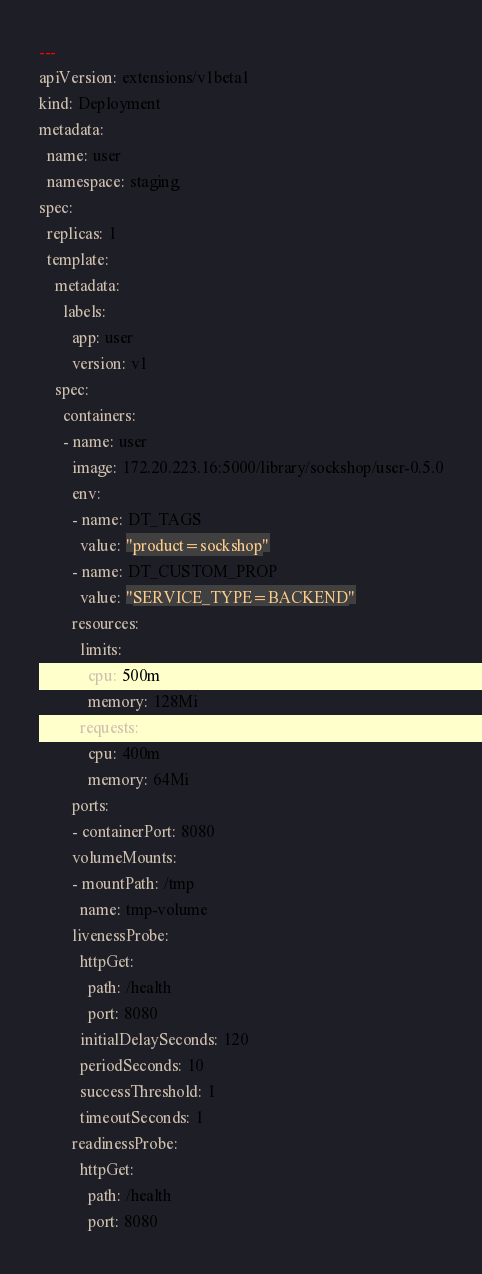Convert code to text. <code><loc_0><loc_0><loc_500><loc_500><_YAML_>---
apiVersion: extensions/v1beta1
kind: Deployment
metadata:
  name: user
  namespace: staging
spec:
  replicas: 1
  template:
    metadata:
      labels:
        app: user
        version: v1
    spec:
      containers:
      - name: user
        image: 172.20.223.16:5000/library/sockshop/user-0.5.0
        env: 
        - name: DT_TAGS
          value: "product=sockshop"
        - name: DT_CUSTOM_PROP
          value: "SERVICE_TYPE=BACKEND"
        resources:
          limits:
            cpu: 500m
            memory: 128Mi
          requests:
            cpu: 400m
            memory: 64Mi
        ports:
        - containerPort: 8080
        volumeMounts:
        - mountPath: /tmp
          name: tmp-volume
        livenessProbe:
          httpGet:
            path: /health
            port: 8080
          initialDelaySeconds: 120
          periodSeconds: 10
          successThreshold: 1
          timeoutSeconds: 1
        readinessProbe:
          httpGet:
            path: /health
            port: 8080</code> 